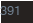Convert code to text. <code><loc_0><loc_0><loc_500><loc_500><_C_>
</code> 